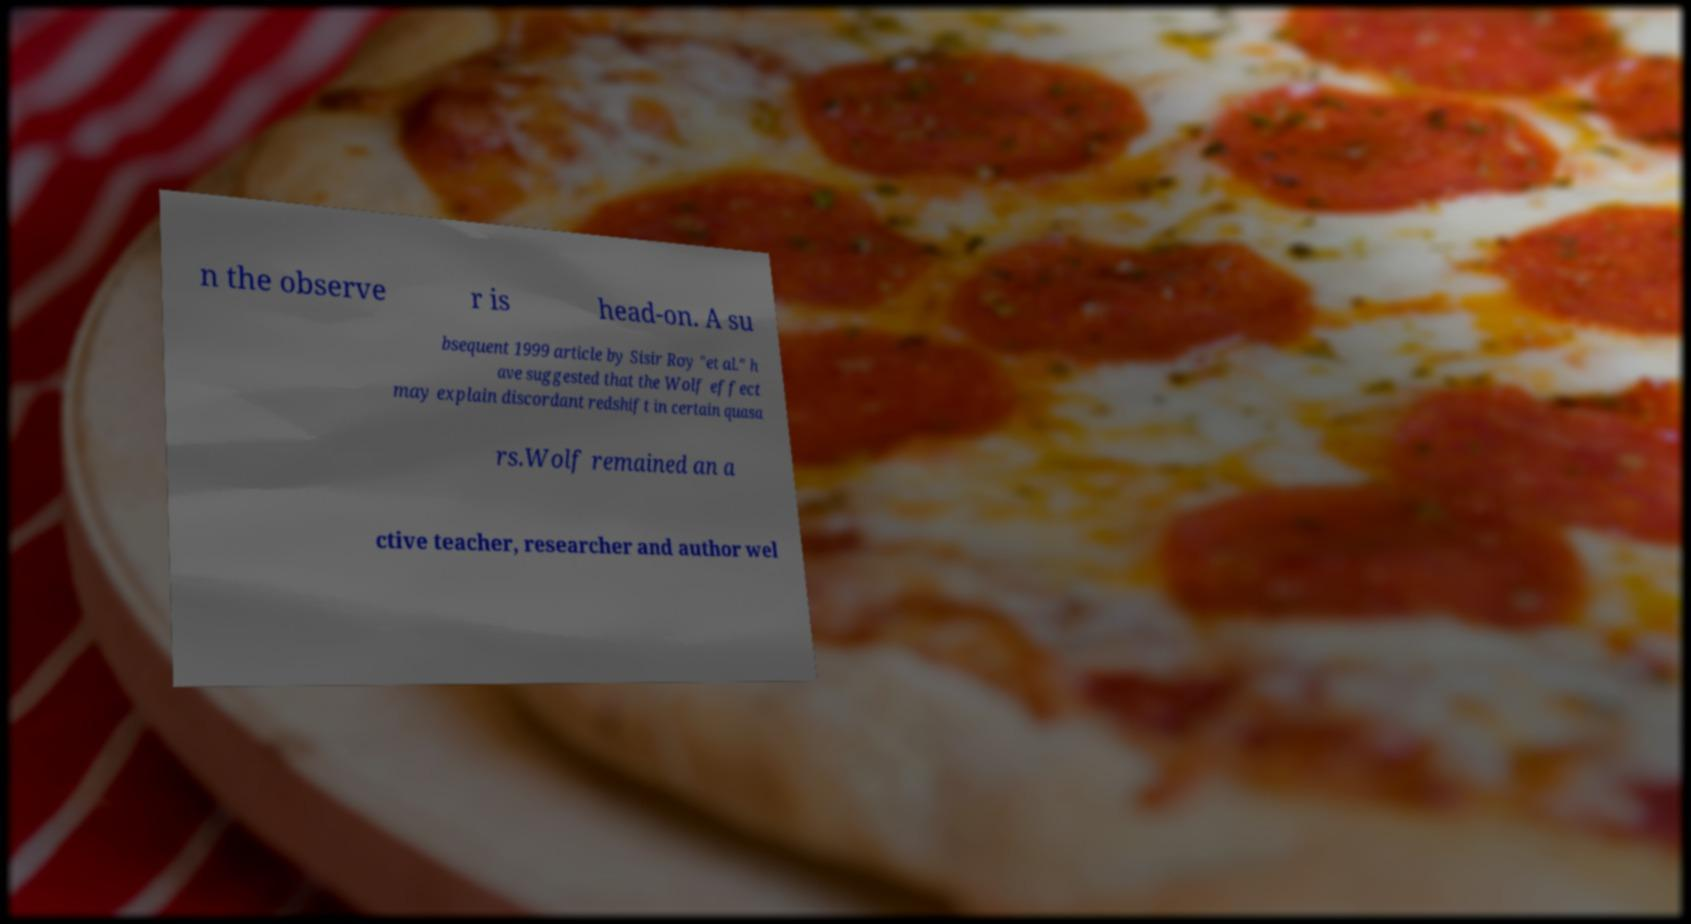For documentation purposes, I need the text within this image transcribed. Could you provide that? n the observe r is head-on. A su bsequent 1999 article by Sisir Roy "et al." h ave suggested that the Wolf effect may explain discordant redshift in certain quasa rs.Wolf remained an a ctive teacher, researcher and author wel 